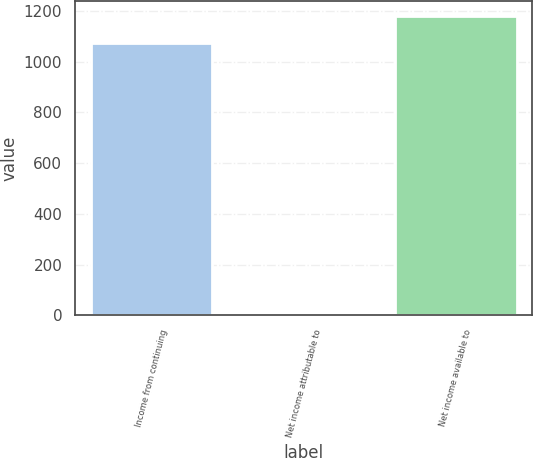<chart> <loc_0><loc_0><loc_500><loc_500><bar_chart><fcel>Income from continuing<fcel>Net income attributable to<fcel>Net income available to<nl><fcel>1073<fcel>1<fcel>1180.6<nl></chart> 